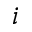Convert formula to latex. <formula><loc_0><loc_0><loc_500><loc_500>i</formula> 